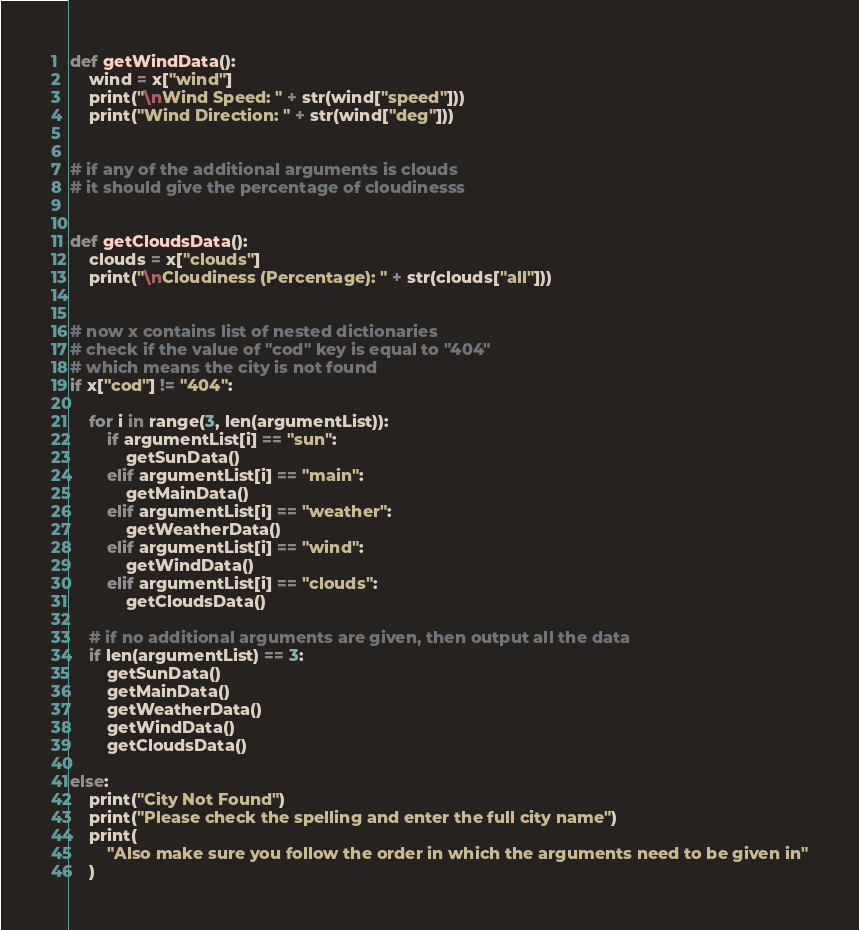Convert code to text. <code><loc_0><loc_0><loc_500><loc_500><_Python_>

def getWindData():
    wind = x["wind"]
    print("\nWind Speed: " + str(wind["speed"]))
    print("Wind Direction: " + str(wind["deg"]))


# if any of the additional arguments is clouds
# it should give the percentage of cloudinesss


def getCloudsData():
    clouds = x["clouds"]
    print("\nCloudiness (Percentage): " + str(clouds["all"]))


# now x contains list of nested dictionaries
# check if the value of "cod" key is equal to "404"
# which means the city is not found
if x["cod"] != "404":

    for i in range(3, len(argumentList)):
        if argumentList[i] == "sun":
            getSunData()
        elif argumentList[i] == "main":
            getMainData()
        elif argumentList[i] == "weather":
            getWeatherData()
        elif argumentList[i] == "wind":
            getWindData()
        elif argumentList[i] == "clouds":
            getCloudsData()

    # if no additional arguments are given, then output all the data
    if len(argumentList) == 3:
        getSunData()
        getMainData()
        getWeatherData()
        getWindData()
        getCloudsData()

else:
    print("City Not Found")
    print("Please check the spelling and enter the full city name")
    print(
        "Also make sure you follow the order in which the arguments need to be given in"
    )
</code> 